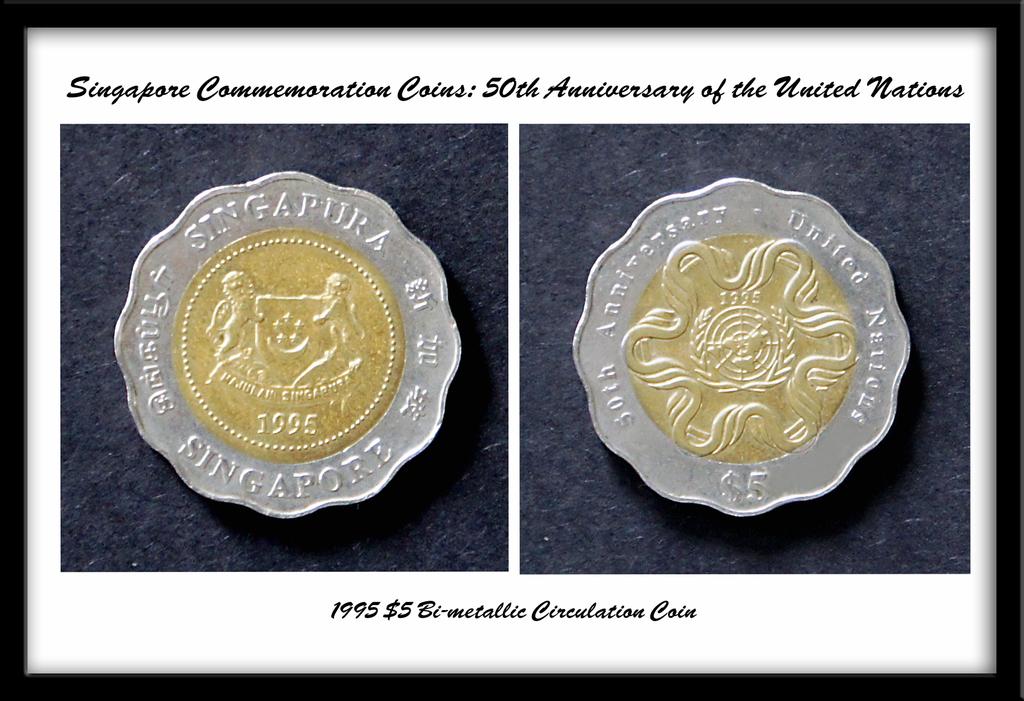What anniversary is shown?
Make the answer very short. 50th. What is the year shown at the bottom?
Provide a succinct answer. 1995. 